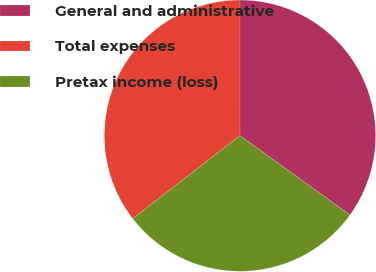Convert chart. <chart><loc_0><loc_0><loc_500><loc_500><pie_chart><fcel>General and administrative<fcel>Total expenses<fcel>Pretax income (loss)<nl><fcel>34.95%<fcel>35.48%<fcel>29.57%<nl></chart> 